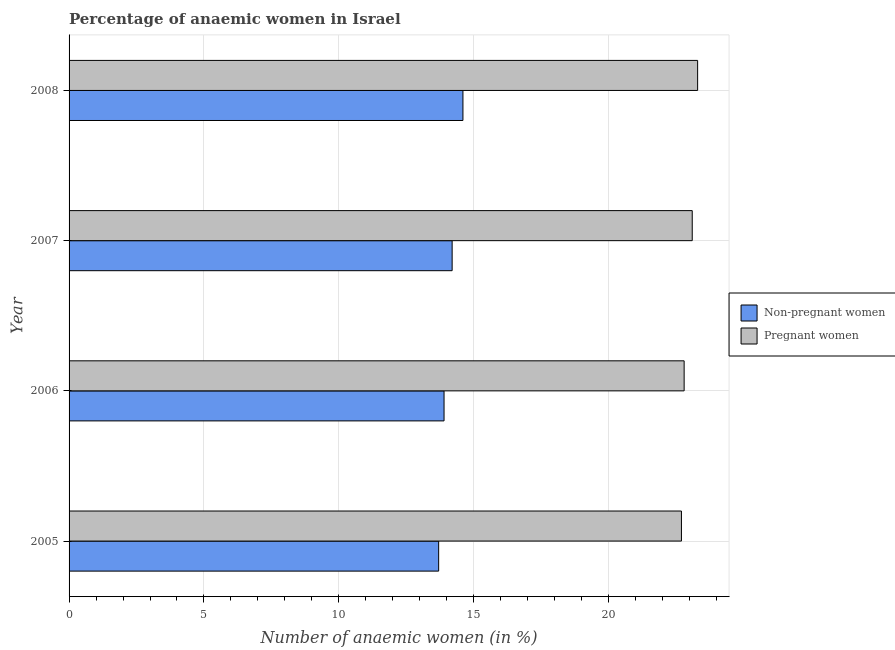How many groups of bars are there?
Give a very brief answer. 4. Are the number of bars per tick equal to the number of legend labels?
Your answer should be very brief. Yes. Are the number of bars on each tick of the Y-axis equal?
Your answer should be compact. Yes. How many bars are there on the 3rd tick from the top?
Give a very brief answer. 2. What is the percentage of non-pregnant anaemic women in 2008?
Give a very brief answer. 14.6. Across all years, what is the maximum percentage of pregnant anaemic women?
Ensure brevity in your answer.  23.3. Across all years, what is the minimum percentage of pregnant anaemic women?
Ensure brevity in your answer.  22.7. In which year was the percentage of pregnant anaemic women maximum?
Provide a short and direct response. 2008. In which year was the percentage of non-pregnant anaemic women minimum?
Your answer should be compact. 2005. What is the total percentage of non-pregnant anaemic women in the graph?
Ensure brevity in your answer.  56.4. What is the difference between the percentage of pregnant anaemic women in 2006 and the percentage of non-pregnant anaemic women in 2007?
Offer a terse response. 8.6. What is the average percentage of pregnant anaemic women per year?
Offer a very short reply. 22.98. In how many years, is the percentage of pregnant anaemic women greater than 7 %?
Offer a very short reply. 4. What is the difference between the highest and the second highest percentage of non-pregnant anaemic women?
Provide a succinct answer. 0.4. In how many years, is the percentage of pregnant anaemic women greater than the average percentage of pregnant anaemic women taken over all years?
Provide a short and direct response. 2. Is the sum of the percentage of pregnant anaemic women in 2005 and 2008 greater than the maximum percentage of non-pregnant anaemic women across all years?
Provide a succinct answer. Yes. What does the 1st bar from the top in 2006 represents?
Offer a terse response. Pregnant women. What does the 2nd bar from the bottom in 2005 represents?
Keep it short and to the point. Pregnant women. What is the difference between two consecutive major ticks on the X-axis?
Provide a succinct answer. 5. Where does the legend appear in the graph?
Offer a very short reply. Center right. How many legend labels are there?
Give a very brief answer. 2. How are the legend labels stacked?
Your answer should be very brief. Vertical. What is the title of the graph?
Provide a succinct answer. Percentage of anaemic women in Israel. Does "Male population" appear as one of the legend labels in the graph?
Offer a very short reply. No. What is the label or title of the X-axis?
Your response must be concise. Number of anaemic women (in %). What is the label or title of the Y-axis?
Your answer should be compact. Year. What is the Number of anaemic women (in %) in Pregnant women in 2005?
Keep it short and to the point. 22.7. What is the Number of anaemic women (in %) of Pregnant women in 2006?
Give a very brief answer. 22.8. What is the Number of anaemic women (in %) of Non-pregnant women in 2007?
Keep it short and to the point. 14.2. What is the Number of anaemic women (in %) of Pregnant women in 2007?
Make the answer very short. 23.1. What is the Number of anaemic women (in %) of Non-pregnant women in 2008?
Give a very brief answer. 14.6. What is the Number of anaemic women (in %) in Pregnant women in 2008?
Provide a succinct answer. 23.3. Across all years, what is the maximum Number of anaemic women (in %) in Pregnant women?
Offer a very short reply. 23.3. Across all years, what is the minimum Number of anaemic women (in %) in Pregnant women?
Provide a short and direct response. 22.7. What is the total Number of anaemic women (in %) of Non-pregnant women in the graph?
Provide a succinct answer. 56.4. What is the total Number of anaemic women (in %) of Pregnant women in the graph?
Make the answer very short. 91.9. What is the difference between the Number of anaemic women (in %) in Non-pregnant women in 2005 and that in 2008?
Keep it short and to the point. -0.9. What is the difference between the Number of anaemic women (in %) of Pregnant women in 2005 and that in 2008?
Provide a succinct answer. -0.6. What is the difference between the Number of anaemic women (in %) in Pregnant women in 2006 and that in 2007?
Your answer should be very brief. -0.3. What is the difference between the Number of anaemic women (in %) in Non-pregnant women in 2006 and that in 2008?
Offer a terse response. -0.7. What is the difference between the Number of anaemic women (in %) of Non-pregnant women in 2007 and that in 2008?
Offer a very short reply. -0.4. What is the difference between the Number of anaemic women (in %) in Non-pregnant women in 2005 and the Number of anaemic women (in %) in Pregnant women in 2007?
Keep it short and to the point. -9.4. What is the difference between the Number of anaemic women (in %) in Non-pregnant women in 2006 and the Number of anaemic women (in %) in Pregnant women in 2007?
Ensure brevity in your answer.  -9.2. What is the difference between the Number of anaemic women (in %) in Non-pregnant women in 2006 and the Number of anaemic women (in %) in Pregnant women in 2008?
Offer a very short reply. -9.4. What is the difference between the Number of anaemic women (in %) of Non-pregnant women in 2007 and the Number of anaemic women (in %) of Pregnant women in 2008?
Give a very brief answer. -9.1. What is the average Number of anaemic women (in %) in Non-pregnant women per year?
Provide a succinct answer. 14.1. What is the average Number of anaemic women (in %) of Pregnant women per year?
Offer a terse response. 22.98. In the year 2006, what is the difference between the Number of anaemic women (in %) of Non-pregnant women and Number of anaemic women (in %) of Pregnant women?
Ensure brevity in your answer.  -8.9. In the year 2007, what is the difference between the Number of anaemic women (in %) in Non-pregnant women and Number of anaemic women (in %) in Pregnant women?
Ensure brevity in your answer.  -8.9. In the year 2008, what is the difference between the Number of anaemic women (in %) in Non-pregnant women and Number of anaemic women (in %) in Pregnant women?
Offer a terse response. -8.7. What is the ratio of the Number of anaemic women (in %) of Non-pregnant women in 2005 to that in 2006?
Your response must be concise. 0.99. What is the ratio of the Number of anaemic women (in %) of Pregnant women in 2005 to that in 2006?
Give a very brief answer. 1. What is the ratio of the Number of anaemic women (in %) in Non-pregnant women in 2005 to that in 2007?
Ensure brevity in your answer.  0.96. What is the ratio of the Number of anaemic women (in %) in Pregnant women in 2005 to that in 2007?
Ensure brevity in your answer.  0.98. What is the ratio of the Number of anaemic women (in %) of Non-pregnant women in 2005 to that in 2008?
Give a very brief answer. 0.94. What is the ratio of the Number of anaemic women (in %) of Pregnant women in 2005 to that in 2008?
Your answer should be compact. 0.97. What is the ratio of the Number of anaemic women (in %) in Non-pregnant women in 2006 to that in 2007?
Give a very brief answer. 0.98. What is the ratio of the Number of anaemic women (in %) in Pregnant women in 2006 to that in 2007?
Offer a terse response. 0.99. What is the ratio of the Number of anaemic women (in %) in Non-pregnant women in 2006 to that in 2008?
Offer a very short reply. 0.95. What is the ratio of the Number of anaemic women (in %) in Pregnant women in 2006 to that in 2008?
Offer a terse response. 0.98. What is the ratio of the Number of anaemic women (in %) of Non-pregnant women in 2007 to that in 2008?
Offer a terse response. 0.97. What is the difference between the highest and the second highest Number of anaemic women (in %) of Non-pregnant women?
Your response must be concise. 0.4. What is the difference between the highest and the second highest Number of anaemic women (in %) of Pregnant women?
Your answer should be compact. 0.2. What is the difference between the highest and the lowest Number of anaemic women (in %) in Pregnant women?
Provide a short and direct response. 0.6. 